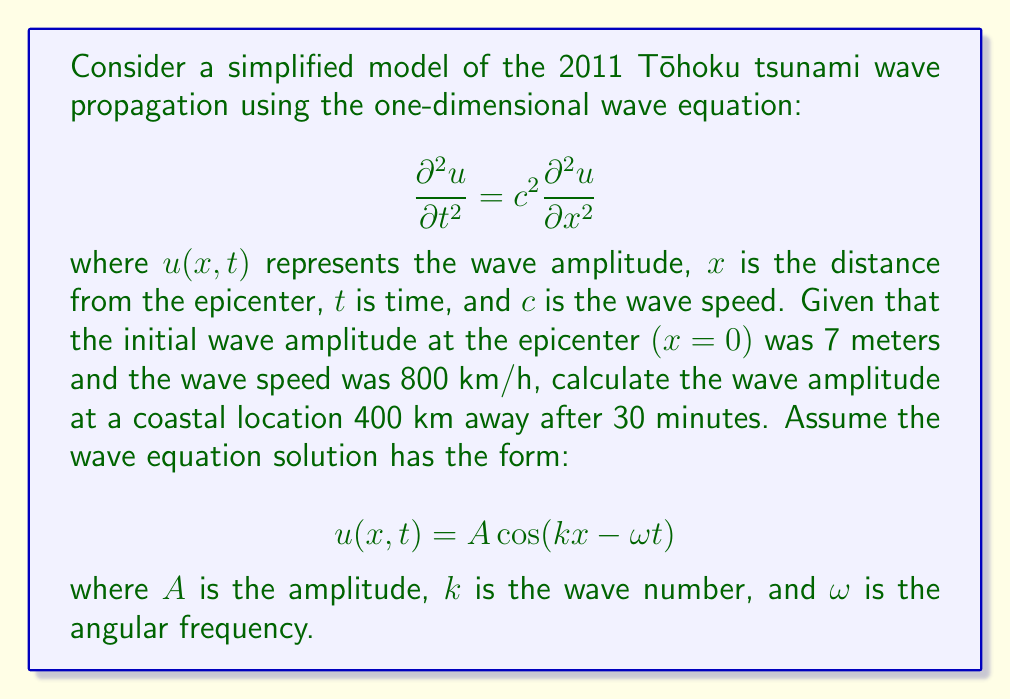Provide a solution to this math problem. To solve this problem, we'll follow these steps:

1) First, we need to convert our units to be consistent. Let's use kilometers and hours:
   - Distance: 400 km
   - Time: 30 minutes = 0.5 hours
   - Wave speed: $c = 800$ km/h

2) We know that for a wave equation solution of the form $u(x,t) = A \cos(kx - \omega t)$:
   - $\omega = ck$
   - $c = \frac{\omega}{k}$

3) We need to find $k$. We can use the fact that the wave travels 400 km in 0.5 hours:
   $$400 = 800 * 0.5$$
   This means one full wavelength is 400 km. The wave number $k$ is related to wavelength $\lambda$ by:
   $$k = \frac{2\pi}{\lambda} = \frac{2\pi}{400} = \frac{\pi}{200}$$

4) Now we can find $\omega$:
   $$\omega = ck = 800 * \frac{\pi}{200} = 4\pi$$

5) Our wave equation solution is now:
   $$u(x,t) = 7 \cos(\frac{\pi x}{200} - 4\pi t)$$

6) To find the amplitude at x = 400 km and t = 0.5 hours, we plug these values in:
   $$u(400, 0.5) = 7 \cos(\frac{\pi * 400}{200} - 4\pi * 0.5)$$
   $$= 7 \cos(2\pi - 2\pi)$$
   $$= 7 \cos(0)$$
   $$= 7$$

Therefore, the wave amplitude at the coastal location after 30 minutes is 7 meters.
Answer: 7 meters 